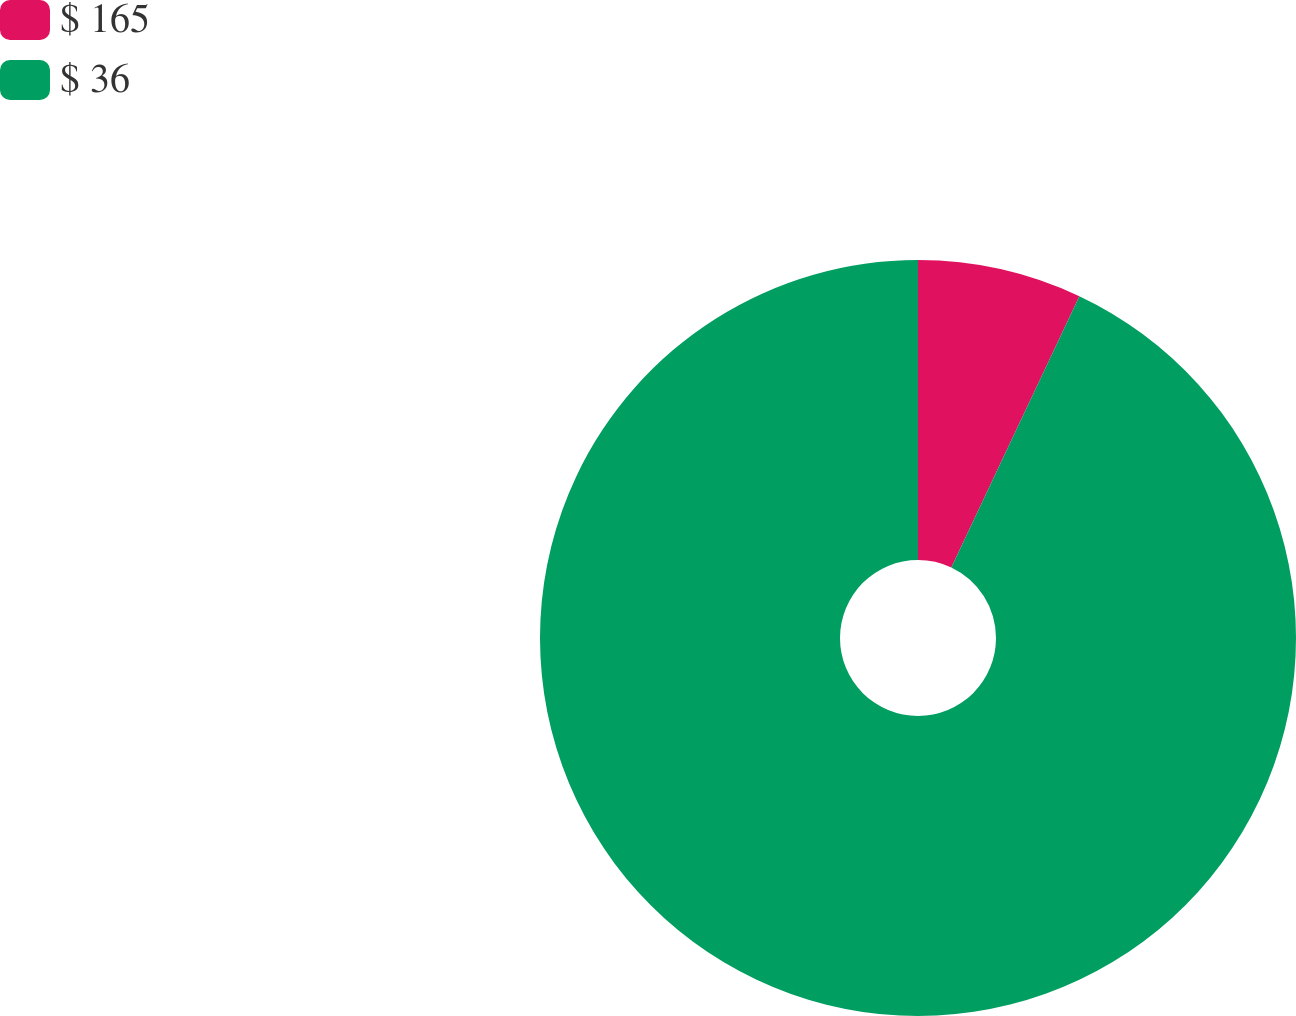Convert chart. <chart><loc_0><loc_0><loc_500><loc_500><pie_chart><fcel>$ 165<fcel>$ 36<nl><fcel>7.02%<fcel>92.98%<nl></chart> 